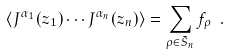Convert formula to latex. <formula><loc_0><loc_0><loc_500><loc_500>\langle J ^ { \alpha _ { 1 } } ( z _ { 1 } ) \cdots J ^ { \alpha _ { n } } ( z _ { n } ) \rangle = \sum _ { \rho \in \tilde { S } _ { n } } f _ { \rho } \ .</formula> 